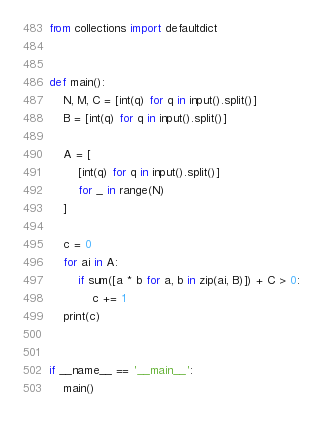<code> <loc_0><loc_0><loc_500><loc_500><_Python_>from collections import defaultdict


def main():
    N, M, C = [int(q) for q in input().split()]
    B = [int(q) for q in input().split()]

    A = [
        [int(q) for q in input().split()]
        for _ in range(N)
    ]

    c = 0
    for ai in A:
        if sum([a * b for a, b in zip(ai, B)]) + C > 0:
            c += 1
    print(c)


if __name__ == '__main__':
    main()
</code> 